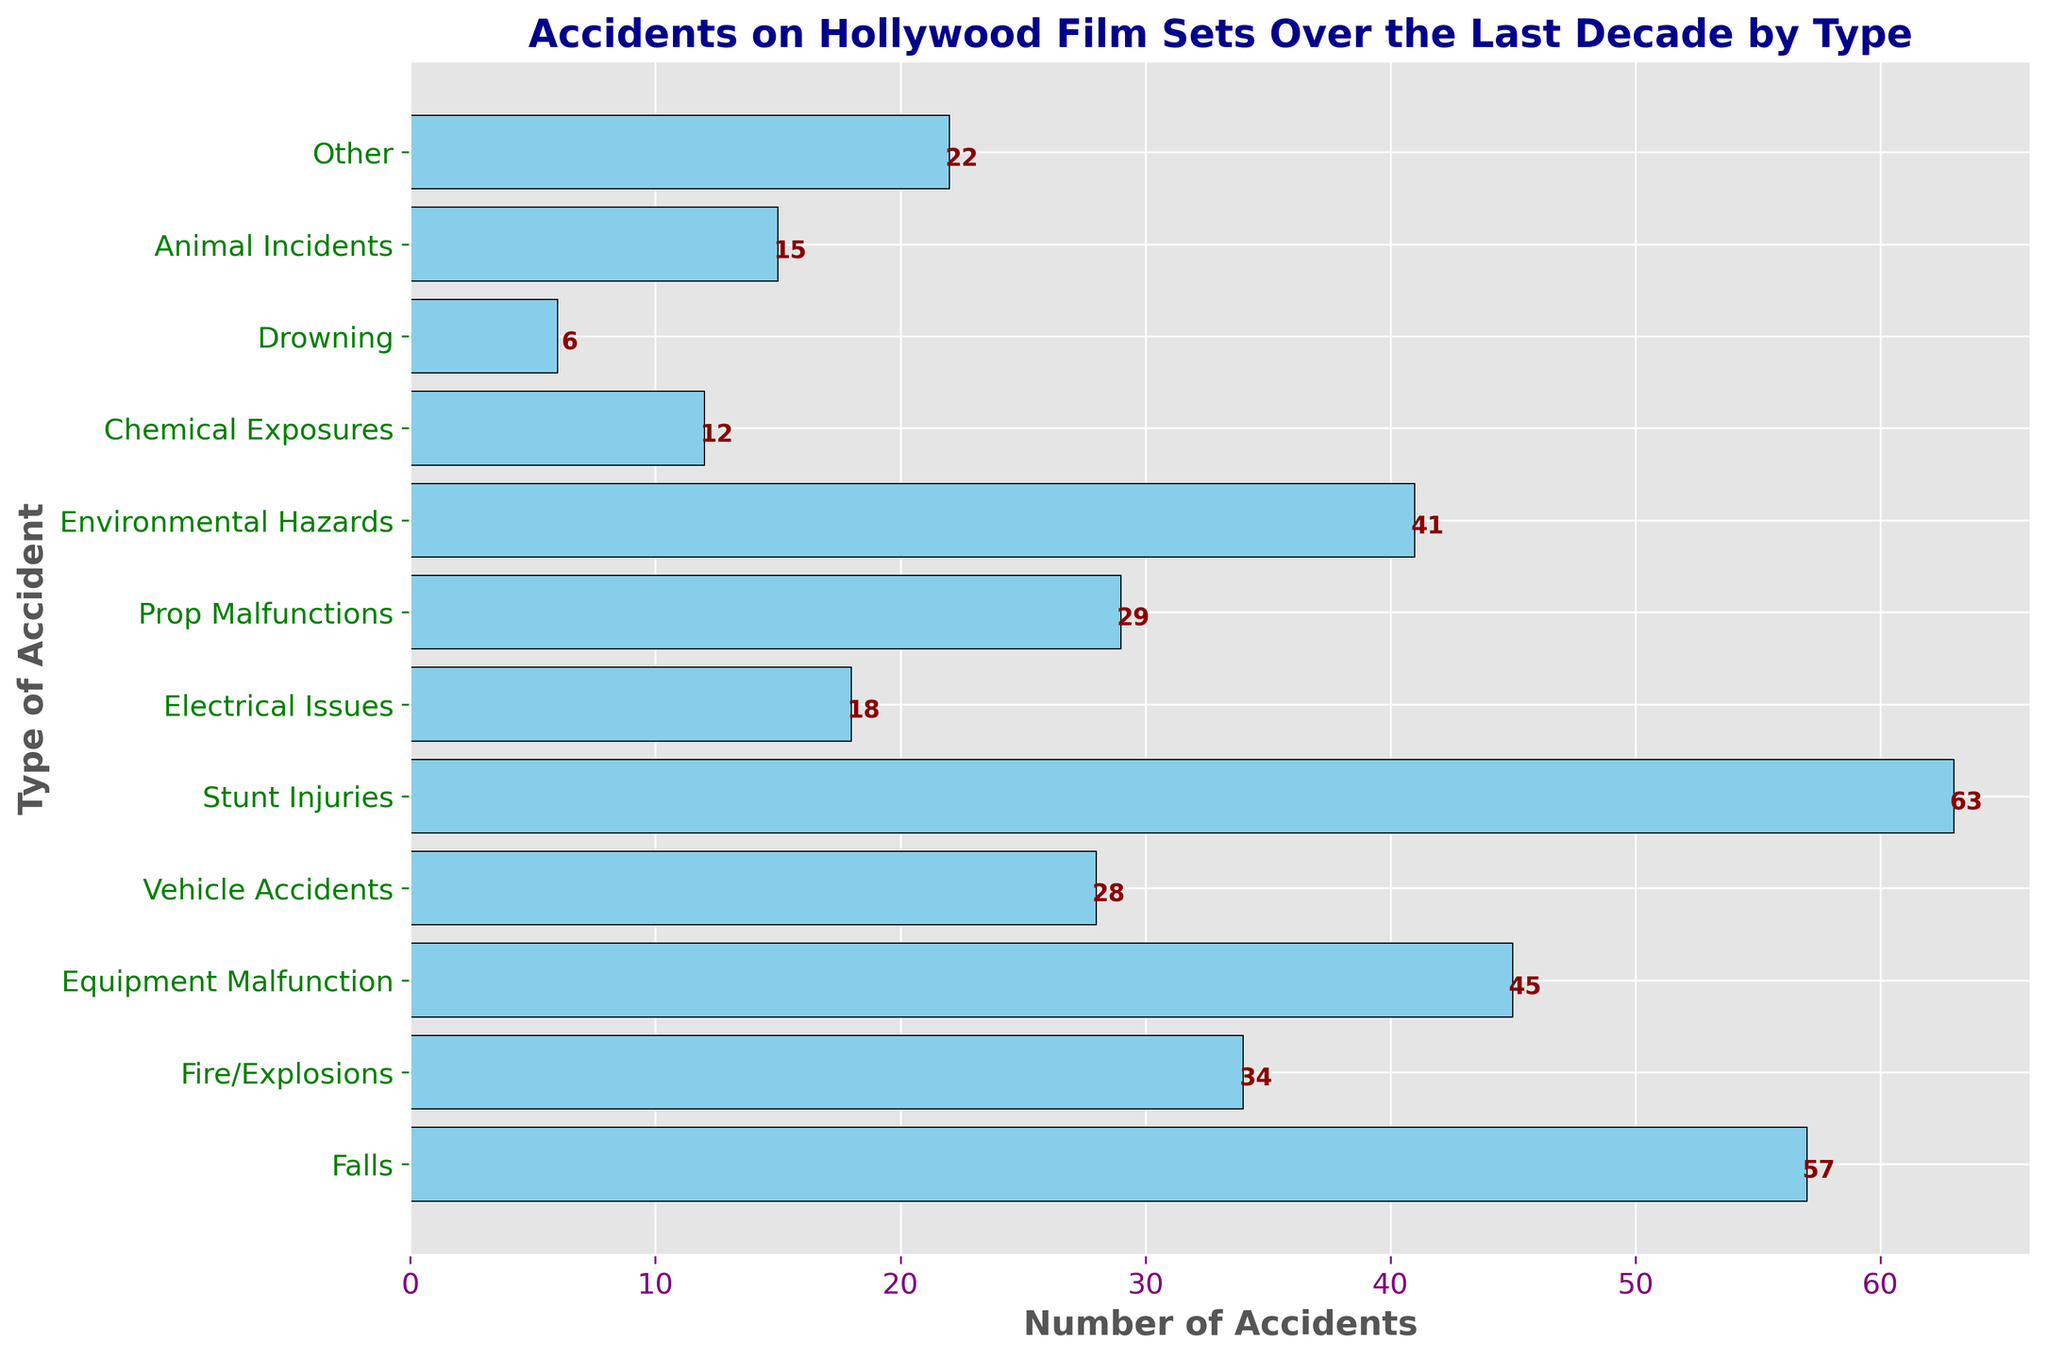What type of accident has the highest count? To find the highest count, look for the longest bar in the histogram. The longest bar represents "Stunt Injuries" with a count of 63.
Answer: Stunt Injuries How many more falls are there compared to drowning incidents? Find the counts for both "Falls" and "Drowning". "Falls" have a count of 57 and "Drowning" has a count of 6. Subtract the count of "Drowning" from "Falls". 57 - 6 = 51.
Answer: 51 What is the total number of accidents involving equipment malfunctions, prop malfunctions, and environmental hazards? Add the counts for "Equipment Malfunction", "Prop Malfunctions", and "Environmental Hazards". 45 (Equipment Malfunction) + 29 (Prop Malfunctions) + 41 (Environmental Hazards) = 115.
Answer: 115 Which type of accident is the second most common? Identify the second longest bar in the histogram. The second longest bar represents "Falls" with a count of 57.
Answer: Falls Are there more fire/explosions or vehicle accidents? Compare the counts for "Fire/Explosions" and "Vehicle Accidents". "Fire/Explosions" have a count of 34, while "Vehicle Accidents" have a count of 28. 34 is greater than 28.
Answer: Fire/Explosions What is the average number of accidents for the categories "Electrical Issues", "Chemical Exposures", and "Animal Incidents"? First, find the counts: "Electrical Issues" (18), "Chemical Exposures" (12), "Animal Incidents" (15). Sum these counts and then divide by the number of categories: (18 + 12 + 15) / 3. The sum is 45, so 45 / 3 = 15.
Answer: 15 Which type of accident has the smallest count? Look for the shortest bar in the histogram. The shortest bar represents "Drowning" with a count of 6.
Answer: Drowning What is the combined count of accidents related to fire/explosions and chemical exposures? Add the counts for "Fire/Explosions" and "Chemical Exposures". 34 (Fire/Explosions) + 12 (Chemical Exposures) = 46.
Answer: 46 What proportion of the accidents are stunt injuries? To find the proportion of "Stunt Injuries", divide the count of "Stunt Injuries" by the total number of accidents and then multiply by 100 to get the percentage. The total number of accidents is the sum of all counts: 57 (Falls) + 34 (Fire/Explosions) + 45 (Equipment Malfunction) + 28 (Vehicle Accidents) + 63 (Stunt Injuries) + 18 (Electrical Issues) + 29 (Prop Malfunctions) + 41 (Environmental Hazards) + 12 (Chemical Exposures) + 6 (Drowning) + 15 (Animal Incidents) + 22 (Other) = 370. The proportion is (63 / 370) * 100 ≈ 17.03%.
Answer: 17.03% How many types of accidents have counts lower than 30? Identify the bars with counts below 30. These types are "Vehicle Accidents" (28), "Electrical Issues" (18), "Prop Malfunctions" (29), "Chemical Exposures" (12), "Drowning" (6), and "Animal Incidents" (15). Count these categories. There are 6 such types.
Answer: 6 